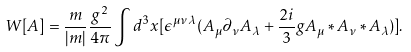<formula> <loc_0><loc_0><loc_500><loc_500>W [ A ] = \frac { m } { | m | } \frac { g ^ { 2 } } { 4 \pi } \int d ^ { 3 } x [ \epsilon ^ { \mu \nu \lambda } ( A _ { \mu } \partial _ { \nu } A _ { \lambda } + \frac { 2 i } { 3 } g A _ { \mu } * A _ { \nu } * A _ { \lambda } ) ] . \\</formula> 